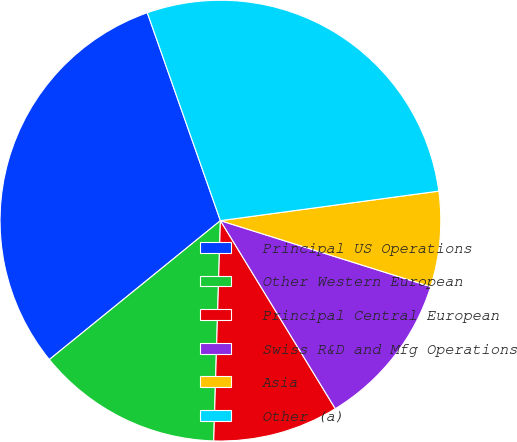Convert chart to OTSL. <chart><loc_0><loc_0><loc_500><loc_500><pie_chart><fcel>Principal US Operations<fcel>Other Western European<fcel>Principal Central European<fcel>Swiss R&D and Mfg Operations<fcel>Asia<fcel>Other (a)<nl><fcel>30.47%<fcel>13.66%<fcel>9.21%<fcel>11.43%<fcel>6.98%<fcel>28.24%<nl></chart> 